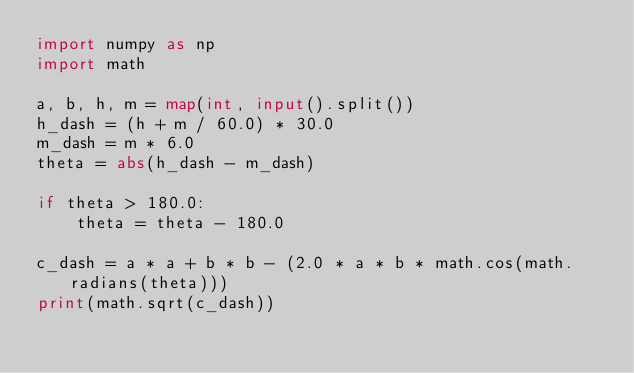<code> <loc_0><loc_0><loc_500><loc_500><_Python_>import numpy as np
import math

a, b, h, m = map(int, input().split())
h_dash = (h + m / 60.0) * 30.0
m_dash = m * 6.0
theta = abs(h_dash - m_dash)

if theta > 180.0:
    theta = theta - 180.0

c_dash = a * a + b * b - (2.0 * a * b * math.cos(math.radians(theta)))
print(math.sqrt(c_dash))
</code> 